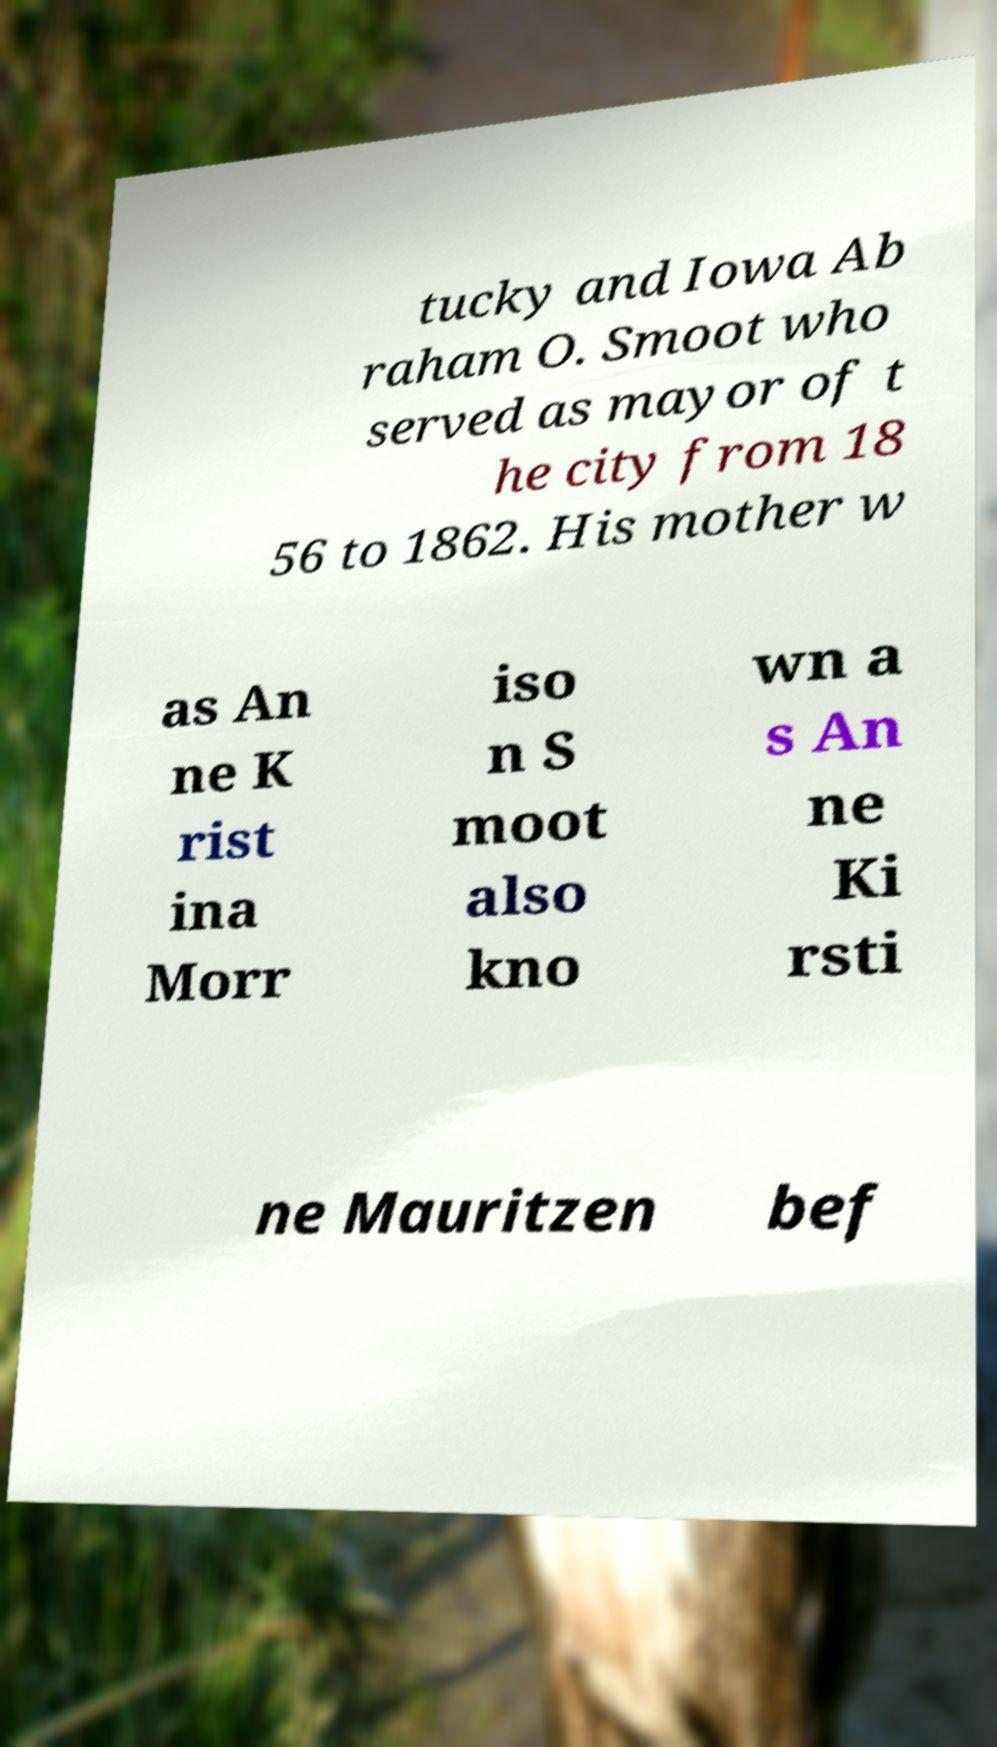Can you read and provide the text displayed in the image?This photo seems to have some interesting text. Can you extract and type it out for me? tucky and Iowa Ab raham O. Smoot who served as mayor of t he city from 18 56 to 1862. His mother w as An ne K rist ina Morr iso n S moot also kno wn a s An ne Ki rsti ne Mauritzen bef 